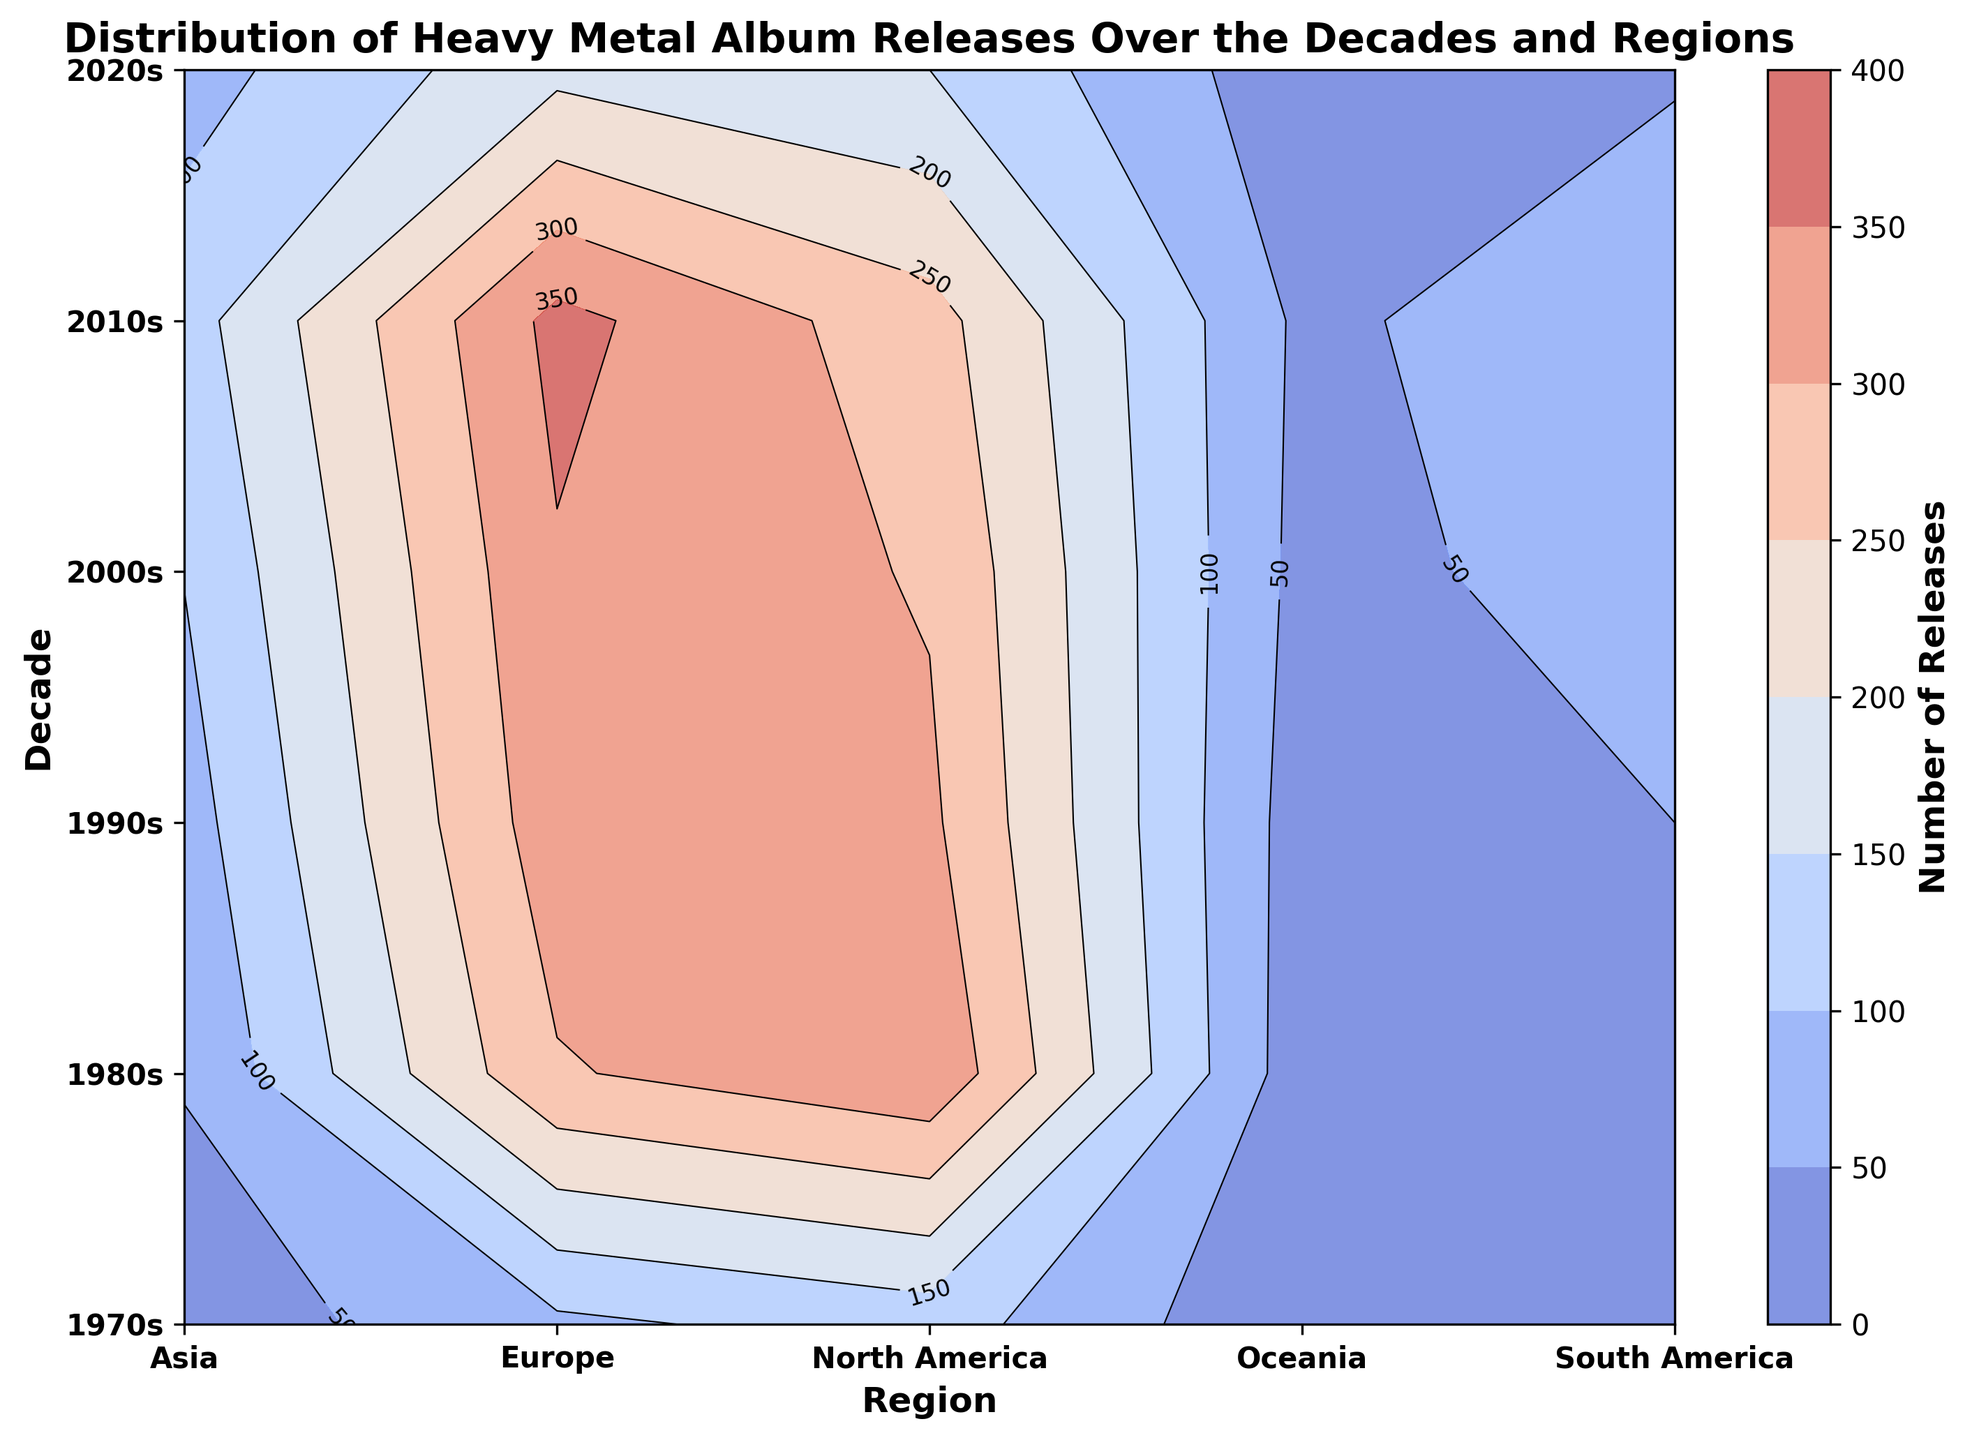What decade saw the highest number of heavy metal album releases in Europe? Look at the contour plot's Y-axis and the color intensity for Europe. The 2010s decade in Europe shows the highest number of releases with the darkest color shade.
Answer: 2010s How many album releases were there in North America and Europe combined in the 1980s? Sum the values of releases in North America and Europe for the 1980s. North America has 342 releases and Europe has 295 releases, so 342 + 295 = 637.
Answer: 637 Which region had the fewest heavy metal album releases in the 2020s? Observe the color shades in the contour plot for the 2020s decade. Oceania has the lightest color, hence the fewest releases.
Answer: Oceania How did the number of releases in North America change from the 1980s to the 2020s? Compare the number of releases in the 1980s and the 2020s for North America. In the 1980s, there are 342 releases, and in the 2020s, there are 150 releases. The change is 150 - 342 = -192.
Answer: Decreased by 192 In which decade did Asia see the greatest increase in heavy metal album releases? Calculate the difference in releases for each consecutive decade in Asia and identify the maximum. The major jumps are 2000s-1990s: 102 - 78 = 24, 2010s-2000s: 128 - 102 = 26, 2020s-2010s: 80 - 128 = -48. The greatest increase is from the 2000s to 2010s.
Answer: 2000s to 2010s Which regions had an increase in heavy metal album releases every decade from the 1970s to the 2010s? Check for an increasing trend in the number of releases for each decade for all regions between the 1970s and 2010s. Europe and Asia show a consistent increase over the periods.
Answer: Europe, Asia What is the trend in South America's heavy metal album releases from the 1980s to the 2020s? Analyze the direction of changes in album releases for South America from the 1980s to the 2020s. Releases are 42 (1980s), 50 (1990s), 72 (2000s), 85 (2010s), 45 (2020s). The trend shows a rise until the 2010s and a drop in the 2020s.
Answer: Increasing until 2010s, then decreasing What is the total number of heavy metal album releases in the 1990s across all regions? Add up the releases for all regions in the 1990s. North America: 310, Europe: 330, Asia: 78, South America: 50, Oceania: 25. Total is 310 + 330 + 78 + 50 + 25 = 793.
Answer: 793 